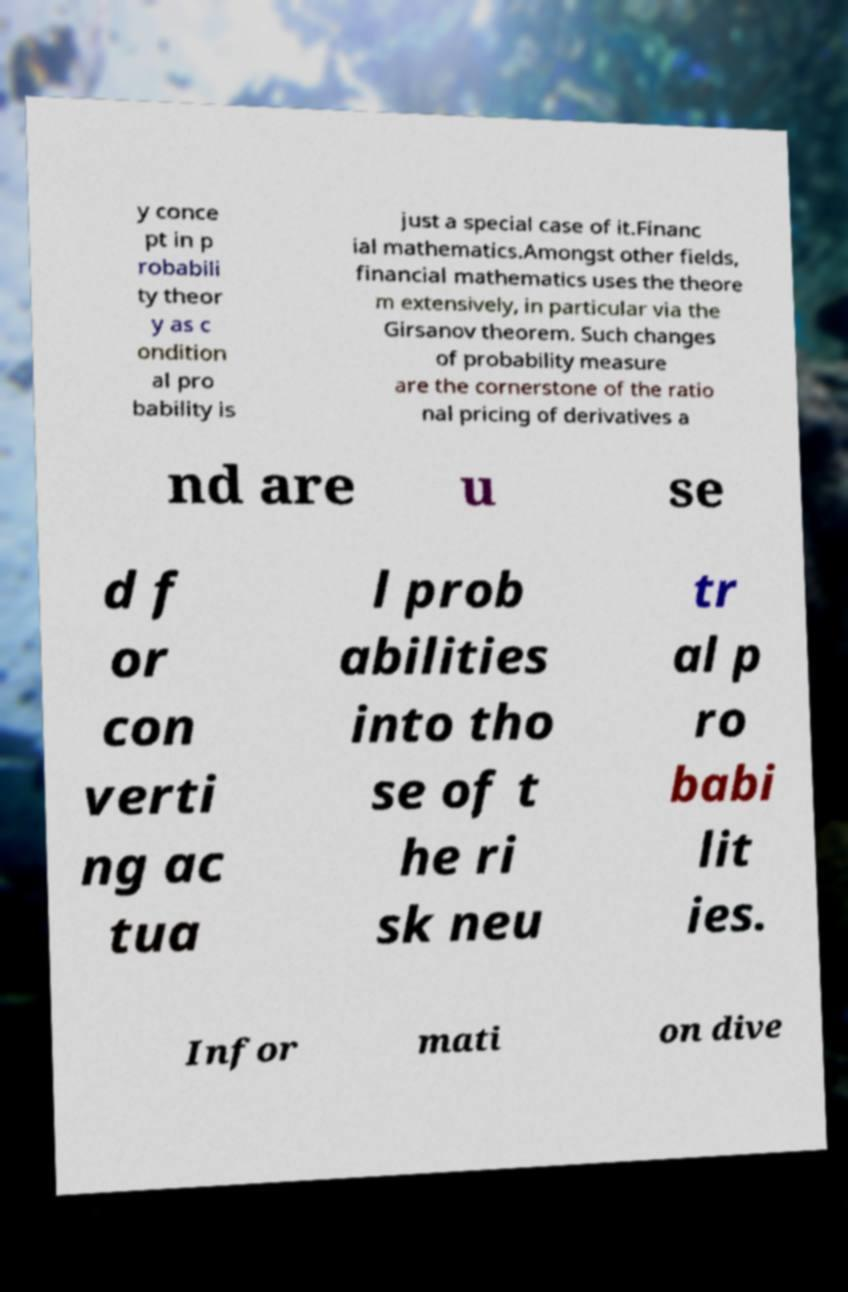Can you accurately transcribe the text from the provided image for me? y conce pt in p robabili ty theor y as c ondition al pro bability is just a special case of it.Financ ial mathematics.Amongst other fields, financial mathematics uses the theore m extensively, in particular via the Girsanov theorem. Such changes of probability measure are the cornerstone of the ratio nal pricing of derivatives a nd are u se d f or con verti ng ac tua l prob abilities into tho se of t he ri sk neu tr al p ro babi lit ies. Infor mati on dive 